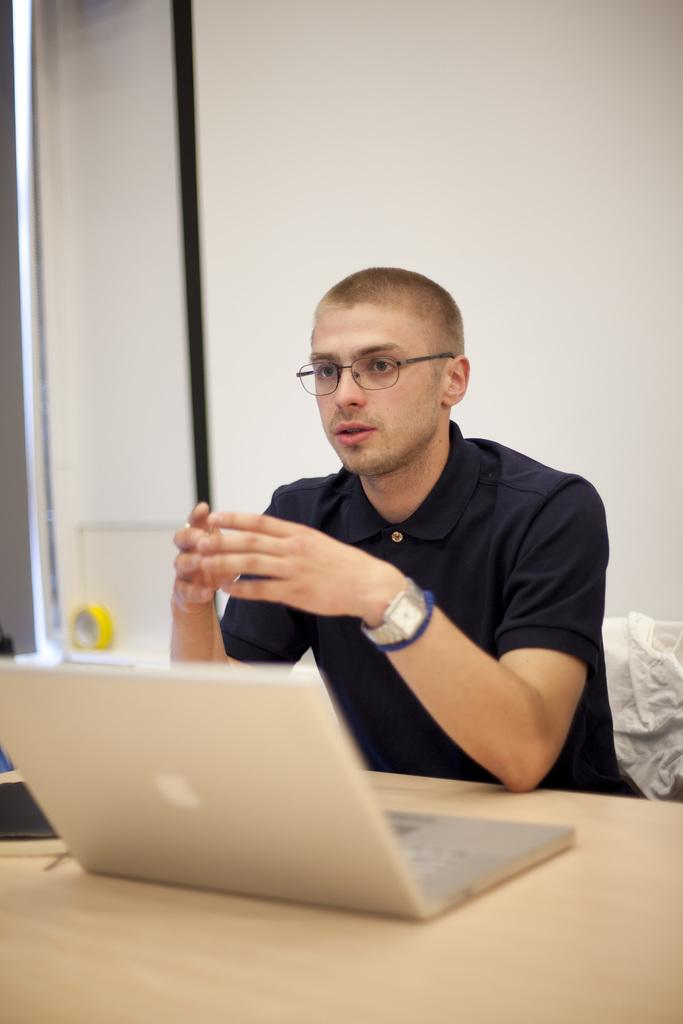Who is present in the image? There is a man in the image. What is the man wearing on his face? The man is wearing spectacles. What accessory is the man wearing on his wrist? The man is wearing a watch. What is the man's position in the image? The man is sitting on a chair. Where is the chair located in relation to the table? The chair is in front of a table. What electronic device is on the table? There is a laptop on the table. What color is the background of the image? The background of the image is white. What type of spark can be seen coming from the man's watch in the image? There is no spark coming from the man's watch in the image. What memory is the man trying to recall while sitting on the chair? The image does not provide any information about the man's thoughts or memories. 